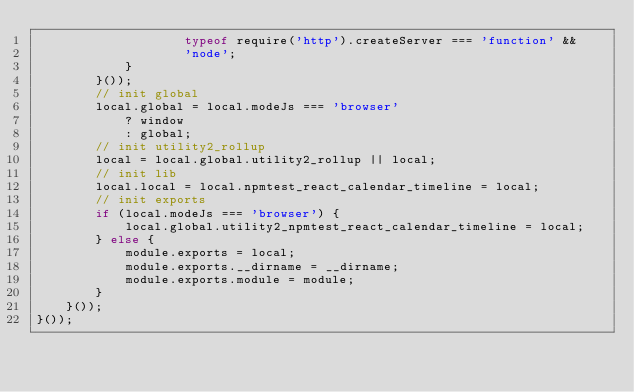<code> <loc_0><loc_0><loc_500><loc_500><_JavaScript_>                    typeof require('http').createServer === 'function' &&
                    'node';
            }
        }());
        // init global
        local.global = local.modeJs === 'browser'
            ? window
            : global;
        // init utility2_rollup
        local = local.global.utility2_rollup || local;
        // init lib
        local.local = local.npmtest_react_calendar_timeline = local;
        // init exports
        if (local.modeJs === 'browser') {
            local.global.utility2_npmtest_react_calendar_timeline = local;
        } else {
            module.exports = local;
            module.exports.__dirname = __dirname;
            module.exports.module = module;
        }
    }());
}());
</code> 